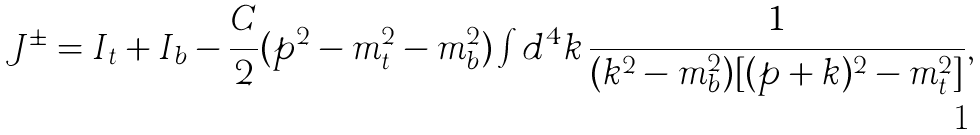Convert formula to latex. <formula><loc_0><loc_0><loc_500><loc_500>J ^ { \pm } = I _ { t } + I _ { b } - \frac { C } { 2 } ( p ^ { 2 } - m _ { t } ^ { 2 } - m _ { b } ^ { 2 } ) \int d ^ { 4 } k \, \frac { 1 } { ( k ^ { 2 } - m _ { b } ^ { 2 } ) [ ( p + k ) ^ { 2 } - m _ { t } ^ { 2 } ] } ,</formula> 